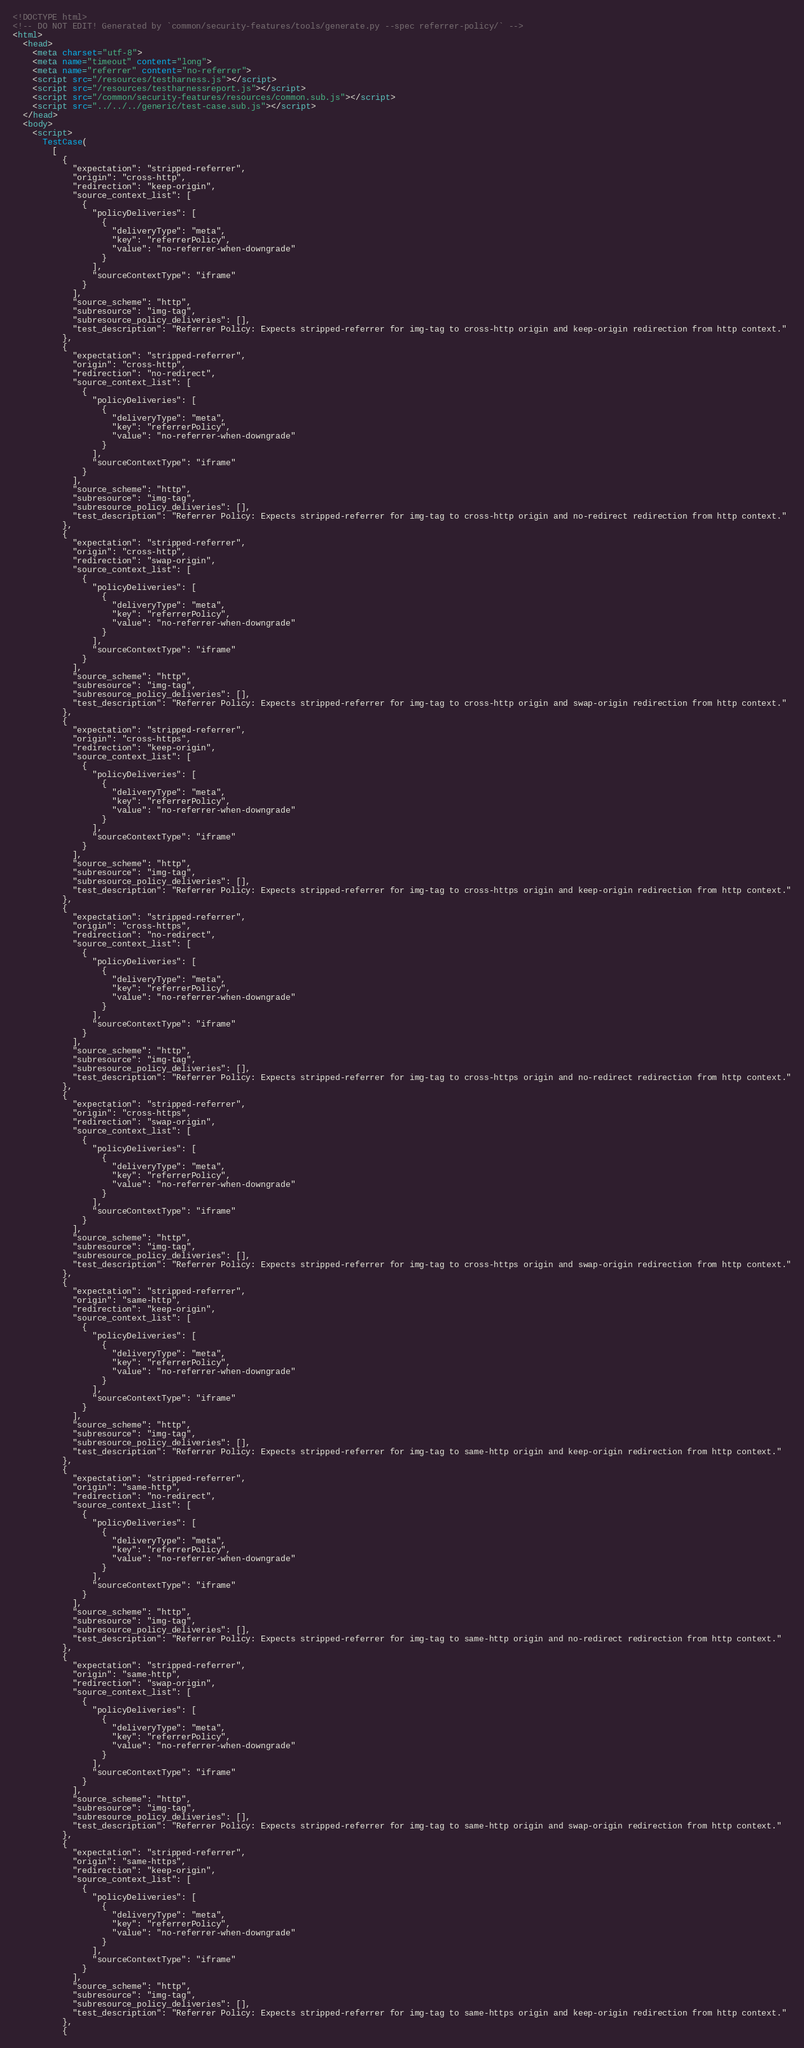<code> <loc_0><loc_0><loc_500><loc_500><_HTML_><!DOCTYPE html>
<!-- DO NOT EDIT! Generated by `common/security-features/tools/generate.py --spec referrer-policy/` -->
<html>
  <head>
    <meta charset="utf-8">
    <meta name="timeout" content="long">
    <meta name="referrer" content="no-referrer">
    <script src="/resources/testharness.js"></script>
    <script src="/resources/testharnessreport.js"></script>
    <script src="/common/security-features/resources/common.sub.js"></script>
    <script src="../../../generic/test-case.sub.js"></script>
  </head>
  <body>
    <script>
      TestCase(
        [
          {
            "expectation": "stripped-referrer",
            "origin": "cross-http",
            "redirection": "keep-origin",
            "source_context_list": [
              {
                "policyDeliveries": [
                  {
                    "deliveryType": "meta",
                    "key": "referrerPolicy",
                    "value": "no-referrer-when-downgrade"
                  }
                ],
                "sourceContextType": "iframe"
              }
            ],
            "source_scheme": "http",
            "subresource": "img-tag",
            "subresource_policy_deliveries": [],
            "test_description": "Referrer Policy: Expects stripped-referrer for img-tag to cross-http origin and keep-origin redirection from http context."
          },
          {
            "expectation": "stripped-referrer",
            "origin": "cross-http",
            "redirection": "no-redirect",
            "source_context_list": [
              {
                "policyDeliveries": [
                  {
                    "deliveryType": "meta",
                    "key": "referrerPolicy",
                    "value": "no-referrer-when-downgrade"
                  }
                ],
                "sourceContextType": "iframe"
              }
            ],
            "source_scheme": "http",
            "subresource": "img-tag",
            "subresource_policy_deliveries": [],
            "test_description": "Referrer Policy: Expects stripped-referrer for img-tag to cross-http origin and no-redirect redirection from http context."
          },
          {
            "expectation": "stripped-referrer",
            "origin": "cross-http",
            "redirection": "swap-origin",
            "source_context_list": [
              {
                "policyDeliveries": [
                  {
                    "deliveryType": "meta",
                    "key": "referrerPolicy",
                    "value": "no-referrer-when-downgrade"
                  }
                ],
                "sourceContextType": "iframe"
              }
            ],
            "source_scheme": "http",
            "subresource": "img-tag",
            "subresource_policy_deliveries": [],
            "test_description": "Referrer Policy: Expects stripped-referrer for img-tag to cross-http origin and swap-origin redirection from http context."
          },
          {
            "expectation": "stripped-referrer",
            "origin": "cross-https",
            "redirection": "keep-origin",
            "source_context_list": [
              {
                "policyDeliveries": [
                  {
                    "deliveryType": "meta",
                    "key": "referrerPolicy",
                    "value": "no-referrer-when-downgrade"
                  }
                ],
                "sourceContextType": "iframe"
              }
            ],
            "source_scheme": "http",
            "subresource": "img-tag",
            "subresource_policy_deliveries": [],
            "test_description": "Referrer Policy: Expects stripped-referrer for img-tag to cross-https origin and keep-origin redirection from http context."
          },
          {
            "expectation": "stripped-referrer",
            "origin": "cross-https",
            "redirection": "no-redirect",
            "source_context_list": [
              {
                "policyDeliveries": [
                  {
                    "deliveryType": "meta",
                    "key": "referrerPolicy",
                    "value": "no-referrer-when-downgrade"
                  }
                ],
                "sourceContextType": "iframe"
              }
            ],
            "source_scheme": "http",
            "subresource": "img-tag",
            "subresource_policy_deliveries": [],
            "test_description": "Referrer Policy: Expects stripped-referrer for img-tag to cross-https origin and no-redirect redirection from http context."
          },
          {
            "expectation": "stripped-referrer",
            "origin": "cross-https",
            "redirection": "swap-origin",
            "source_context_list": [
              {
                "policyDeliveries": [
                  {
                    "deliveryType": "meta",
                    "key": "referrerPolicy",
                    "value": "no-referrer-when-downgrade"
                  }
                ],
                "sourceContextType": "iframe"
              }
            ],
            "source_scheme": "http",
            "subresource": "img-tag",
            "subresource_policy_deliveries": [],
            "test_description": "Referrer Policy: Expects stripped-referrer for img-tag to cross-https origin and swap-origin redirection from http context."
          },
          {
            "expectation": "stripped-referrer",
            "origin": "same-http",
            "redirection": "keep-origin",
            "source_context_list": [
              {
                "policyDeliveries": [
                  {
                    "deliveryType": "meta",
                    "key": "referrerPolicy",
                    "value": "no-referrer-when-downgrade"
                  }
                ],
                "sourceContextType": "iframe"
              }
            ],
            "source_scheme": "http",
            "subresource": "img-tag",
            "subresource_policy_deliveries": [],
            "test_description": "Referrer Policy: Expects stripped-referrer for img-tag to same-http origin and keep-origin redirection from http context."
          },
          {
            "expectation": "stripped-referrer",
            "origin": "same-http",
            "redirection": "no-redirect",
            "source_context_list": [
              {
                "policyDeliveries": [
                  {
                    "deliveryType": "meta",
                    "key": "referrerPolicy",
                    "value": "no-referrer-when-downgrade"
                  }
                ],
                "sourceContextType": "iframe"
              }
            ],
            "source_scheme": "http",
            "subresource": "img-tag",
            "subresource_policy_deliveries": [],
            "test_description": "Referrer Policy: Expects stripped-referrer for img-tag to same-http origin and no-redirect redirection from http context."
          },
          {
            "expectation": "stripped-referrer",
            "origin": "same-http",
            "redirection": "swap-origin",
            "source_context_list": [
              {
                "policyDeliveries": [
                  {
                    "deliveryType": "meta",
                    "key": "referrerPolicy",
                    "value": "no-referrer-when-downgrade"
                  }
                ],
                "sourceContextType": "iframe"
              }
            ],
            "source_scheme": "http",
            "subresource": "img-tag",
            "subresource_policy_deliveries": [],
            "test_description": "Referrer Policy: Expects stripped-referrer for img-tag to same-http origin and swap-origin redirection from http context."
          },
          {
            "expectation": "stripped-referrer",
            "origin": "same-https",
            "redirection": "keep-origin",
            "source_context_list": [
              {
                "policyDeliveries": [
                  {
                    "deliveryType": "meta",
                    "key": "referrerPolicy",
                    "value": "no-referrer-when-downgrade"
                  }
                ],
                "sourceContextType": "iframe"
              }
            ],
            "source_scheme": "http",
            "subresource": "img-tag",
            "subresource_policy_deliveries": [],
            "test_description": "Referrer Policy: Expects stripped-referrer for img-tag to same-https origin and keep-origin redirection from http context."
          },
          {</code> 